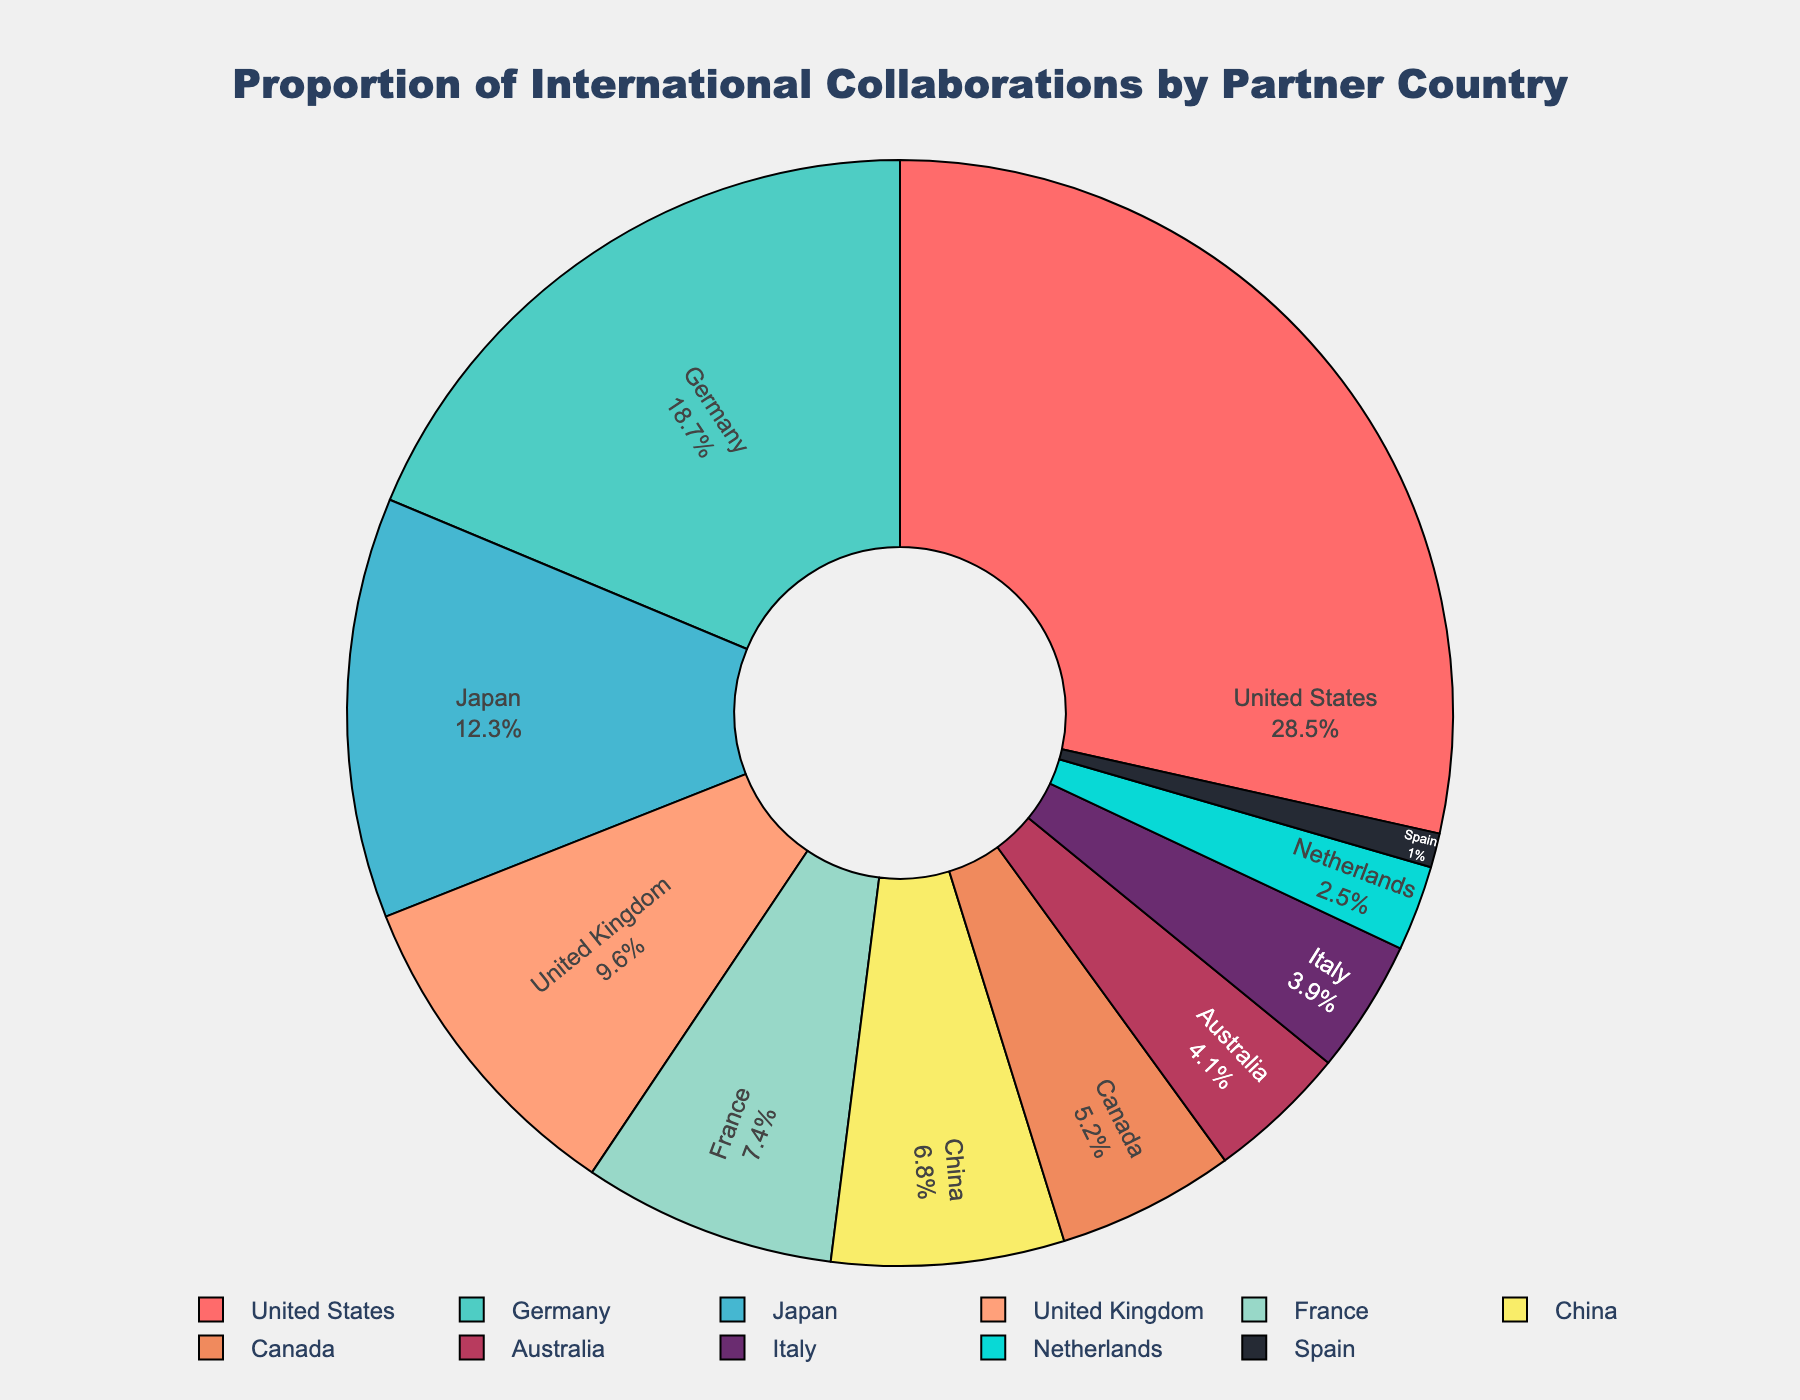Which country has the highest proportion of international collaborations? The country with the highest proportion of international collaborations can be identified by looking at the segment of the pie chart with the largest area and its corresponding label.
Answer: United States Which two countries together account for less than 10% of collaborations? To determine this, look for two countries whose combined percentages on the pie chart add up to less than 10%. From the chart, it's evident that Spain contributes 1.0% and Netherlands contributes 2.5%; their combined total is 3.5%, which is less than 10%.
Answer: Spain and Netherlands How much greater is the proportion of collaborations with the United States compared to China? The proportions for the United States and China are directly labeled on the pie chart. Subtract China's percentage from the United States' percentage: 28.5% - 6.8% = 21.7%.
Answer: 21.7% What is the average percentage of collaborations among Germany, Japan, and the United Kingdom? To find the average, sum the percentages of these three countries and divide by three. (18.7% + 12.3% + 9.6%) / 3 = 13.53%.
Answer: 13.53% Which country has the smallest proportion of international collaborations, and what is the percentage? By identifying the smallest segment on the pie chart, correspondingly labeled, you find the country with the smallest proportion.
Answer: Spain, 1.0% Is the proportion of collaborations with Germany greater than the combined proportion of Canada and Australia? Compare Germany's percentage with the sum of Canada's and Australia's percentages: Germany is 18.7%, and Canada (5.2%) + Australia (4.1%) = 9.3%. 18.7% is greater than 9.3%.
Answer: Yes Which countries have percentages below 5%, and what are their percentages? Identify all segments on the pie chart with less than 5% indicated next to them. These countries are Australia (4.1%), Italy (3.9%), Netherlands (2.5%), and Spain (1.0%).
Answer: Australia (4.1%), Italy (3.9%), Netherlands (2.5%), Spain (1.0%) What is the collective proportion of collaborations for France and China? Sum the percentages of France and China from the pie chart. 7.4% + 6.8% = 14.2%.
Answer: 14.2% Which region (considering traditional European countries) has a larger proportion of collaborations: Germany and France combined or Italy and the Netherlands combined? Calculate the combined percentages: Germany (18.7%) + France (7.4%) = 26.1%; Italy (3.9%) + Netherlands (2.5%) = 6.4%. Germany and France together have a larger proportion than Italy and the Netherlands.
Answer: Germany and France 